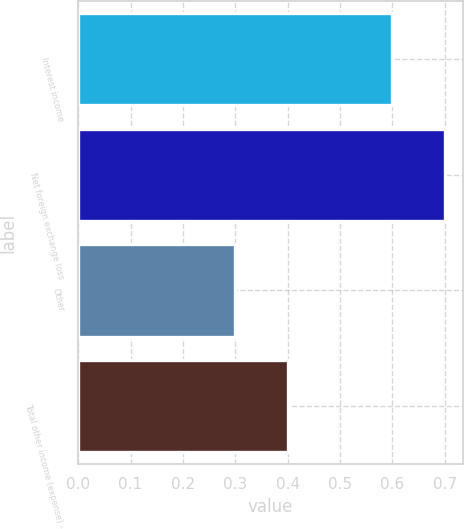Convert chart. <chart><loc_0><loc_0><loc_500><loc_500><bar_chart><fcel>Interest income<fcel>Net foreign exchange loss<fcel>Other<fcel>Total other income (expense) -<nl><fcel>0.6<fcel>0.7<fcel>0.3<fcel>0.4<nl></chart> 